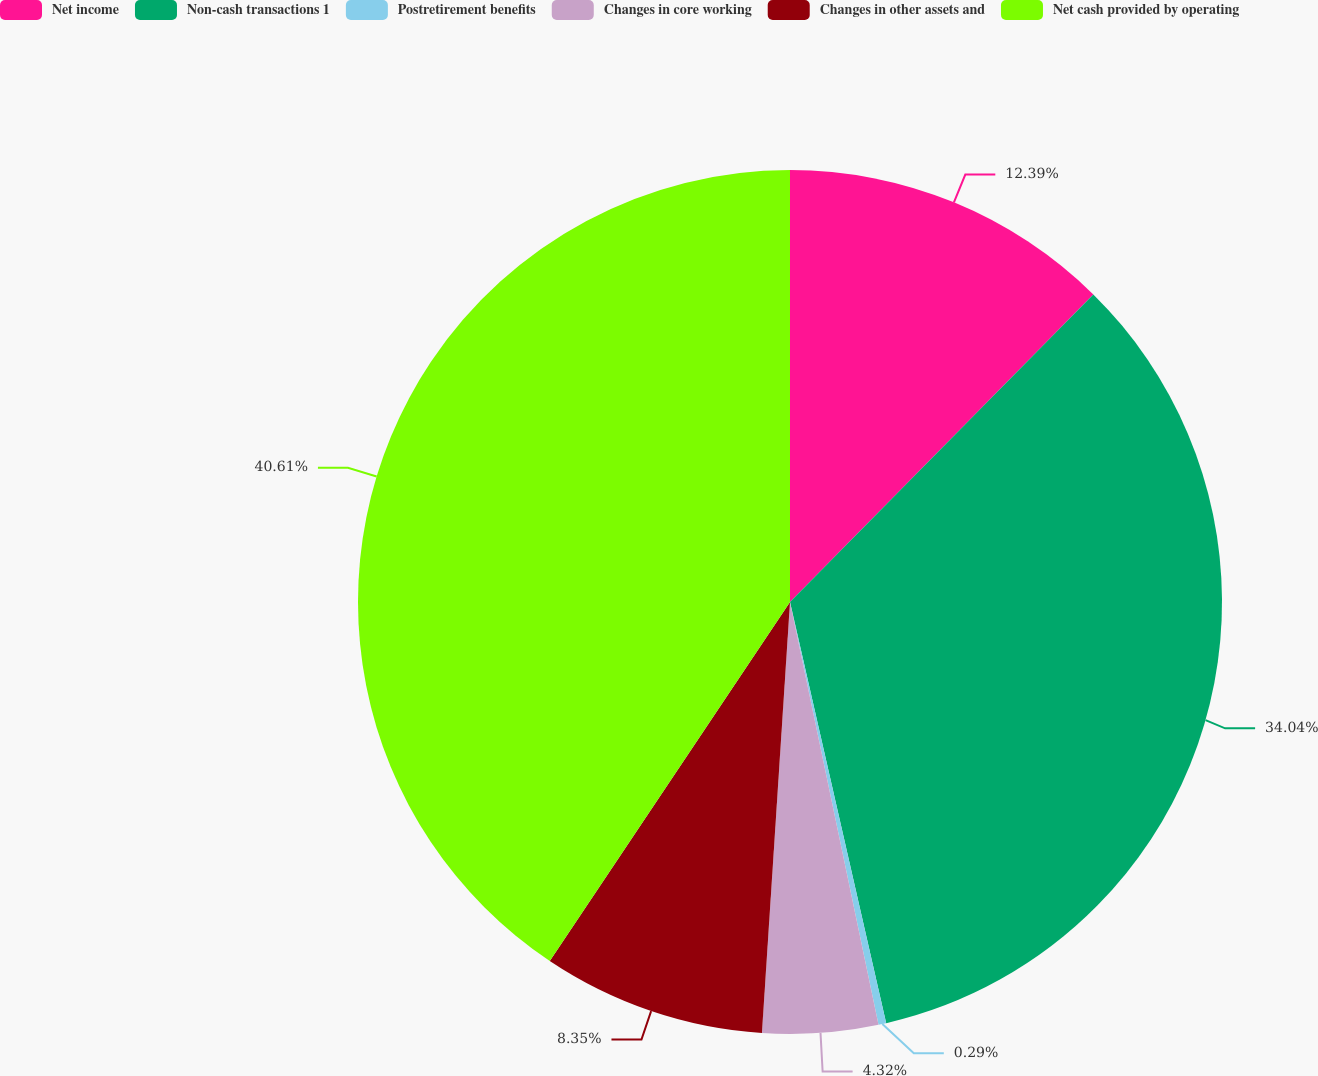<chart> <loc_0><loc_0><loc_500><loc_500><pie_chart><fcel>Net income<fcel>Non-cash transactions 1<fcel>Postretirement benefits<fcel>Changes in core working<fcel>Changes in other assets and<fcel>Net cash provided by operating<nl><fcel>12.39%<fcel>34.04%<fcel>0.29%<fcel>4.32%<fcel>8.35%<fcel>40.62%<nl></chart> 